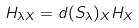Convert formula to latex. <formula><loc_0><loc_0><loc_500><loc_500>H _ { \lambda X } = d ( S _ { \lambda } ) _ { X } H _ { X }</formula> 